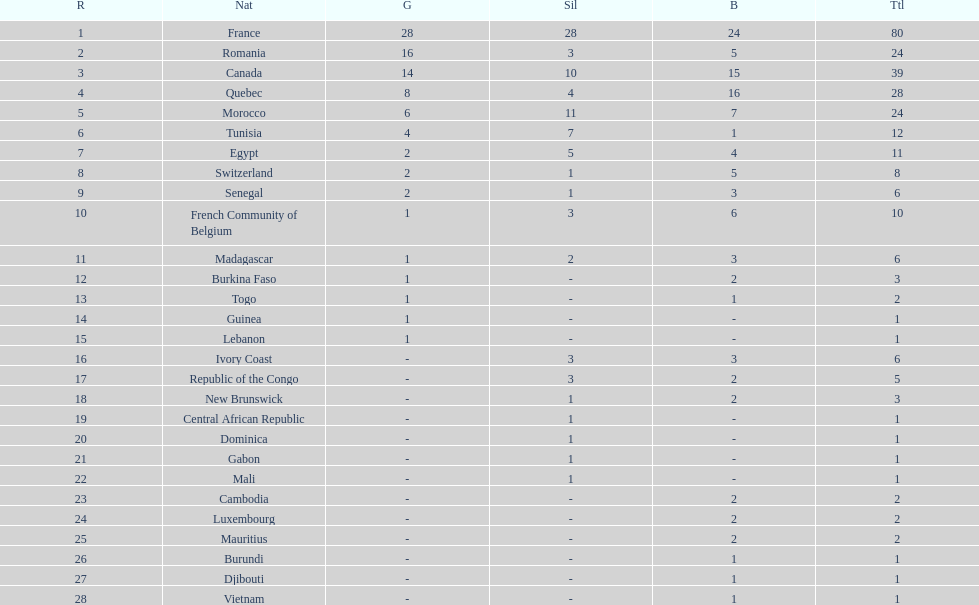Who placed in first according to medals? France. 